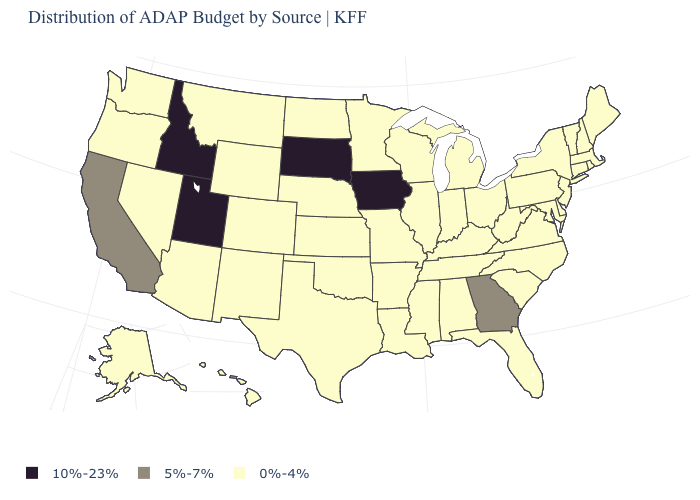What is the highest value in the West ?
Keep it brief. 10%-23%. What is the value of Delaware?
Keep it brief. 0%-4%. What is the value of Maine?
Be succinct. 0%-4%. Among the states that border Texas , which have the highest value?
Concise answer only. Arkansas, Louisiana, New Mexico, Oklahoma. Name the states that have a value in the range 5%-7%?
Keep it brief. California, Georgia. What is the value of Ohio?
Quick response, please. 0%-4%. What is the lowest value in the Northeast?
Keep it brief. 0%-4%. What is the lowest value in the USA?
Keep it brief. 0%-4%. Does the first symbol in the legend represent the smallest category?
Give a very brief answer. No. What is the value of Nebraska?
Concise answer only. 0%-4%. Which states have the highest value in the USA?
Answer briefly. Idaho, Iowa, South Dakota, Utah. Name the states that have a value in the range 0%-4%?
Concise answer only. Alabama, Alaska, Arizona, Arkansas, Colorado, Connecticut, Delaware, Florida, Hawaii, Illinois, Indiana, Kansas, Kentucky, Louisiana, Maine, Maryland, Massachusetts, Michigan, Minnesota, Mississippi, Missouri, Montana, Nebraska, Nevada, New Hampshire, New Jersey, New Mexico, New York, North Carolina, North Dakota, Ohio, Oklahoma, Oregon, Pennsylvania, Rhode Island, South Carolina, Tennessee, Texas, Vermont, Virginia, Washington, West Virginia, Wisconsin, Wyoming. What is the lowest value in states that border Oklahoma?
Be succinct. 0%-4%. What is the lowest value in states that border North Dakota?
Keep it brief. 0%-4%. What is the lowest value in the Northeast?
Quick response, please. 0%-4%. 